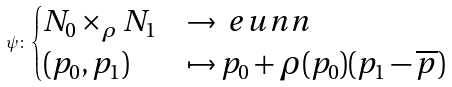Convert formula to latex. <formula><loc_0><loc_0><loc_500><loc_500>\psi \colon \begin{cases} N _ { 0 } \times _ { \rho } N _ { 1 } & \rightarrow \ e u n n \\ ( p _ { 0 } , p _ { 1 } ) & \mapsto p _ { 0 } + \rho ( p _ { 0 } ) ( p _ { 1 } - \overline { p } ) \end{cases}</formula> 